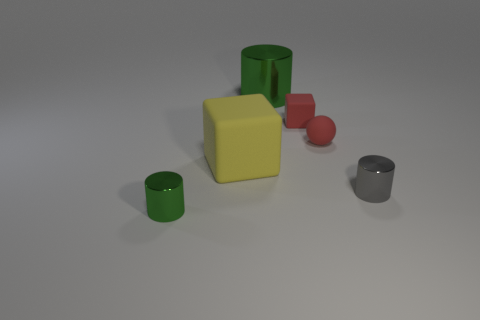What is the material of the green cylinder that is in front of the matte cube that is behind the red matte sphere?
Your answer should be very brief. Metal. What material is the big green cylinder?
Offer a very short reply. Metal. There is a yellow object that is made of the same material as the ball; what is its size?
Make the answer very short. Large. How many large objects are yellow things or brown matte objects?
Provide a short and direct response. 1. There is a green metallic cylinder that is right of the big thing that is to the left of the green metallic object that is behind the big block; how big is it?
Your answer should be very brief. Large. What number of things have the same size as the ball?
Provide a short and direct response. 3. How many things are brown metal cubes or matte things in front of the small block?
Your answer should be very brief. 2. There is a yellow thing; what shape is it?
Ensure brevity in your answer.  Cube. Is the color of the sphere the same as the tiny block?
Give a very brief answer. Yes. The matte object that is the same size as the red block is what color?
Provide a short and direct response. Red. 